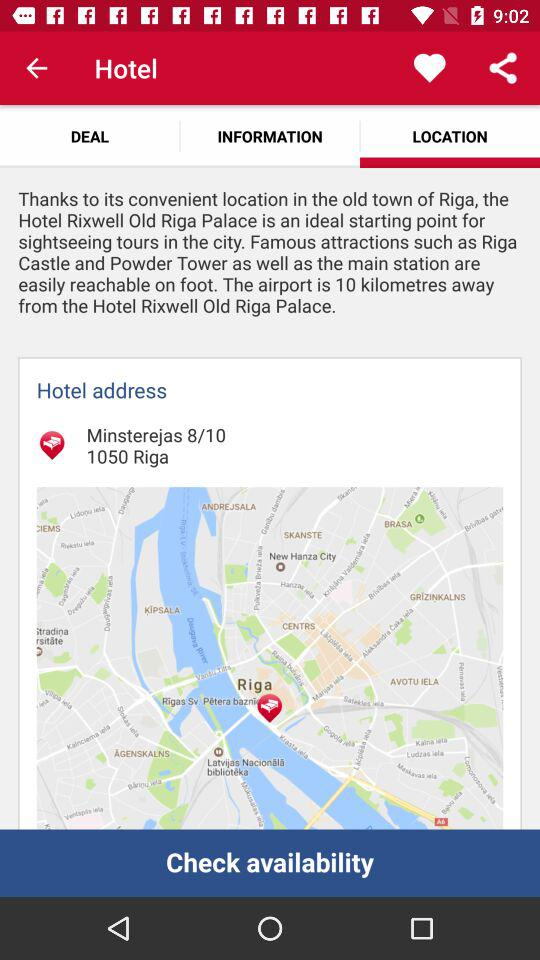What is the hotel name? The hotel name is "Hotel Rixwell Old Riga Palace". 